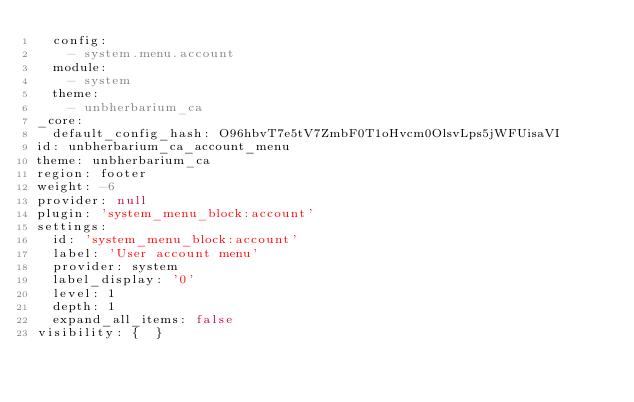<code> <loc_0><loc_0><loc_500><loc_500><_YAML_>  config:
    - system.menu.account
  module:
    - system
  theme:
    - unbherbarium_ca
_core:
  default_config_hash: O96hbvT7e5tV7ZmbF0T1oHvcm0OlsvLps5jWFUisaVI
id: unbherbarium_ca_account_menu
theme: unbherbarium_ca
region: footer
weight: -6
provider: null
plugin: 'system_menu_block:account'
settings:
  id: 'system_menu_block:account'
  label: 'User account menu'
  provider: system
  label_display: '0'
  level: 1
  depth: 1
  expand_all_items: false
visibility: {  }
</code> 